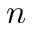Convert formula to latex. <formula><loc_0><loc_0><loc_500><loc_500>n</formula> 